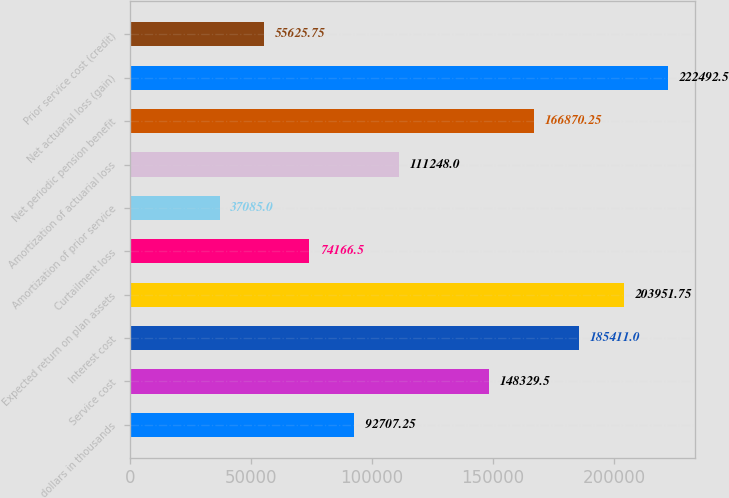<chart> <loc_0><loc_0><loc_500><loc_500><bar_chart><fcel>dollars in thousands<fcel>Service cost<fcel>Interest cost<fcel>Expected return on plan assets<fcel>Curtailment loss<fcel>Amortization of prior service<fcel>Amortization of actuarial loss<fcel>Net periodic pension benefit<fcel>Net actuarial loss (gain)<fcel>Prior service cost (credit)<nl><fcel>92707.2<fcel>148330<fcel>185411<fcel>203952<fcel>74166.5<fcel>37085<fcel>111248<fcel>166870<fcel>222492<fcel>55625.8<nl></chart> 